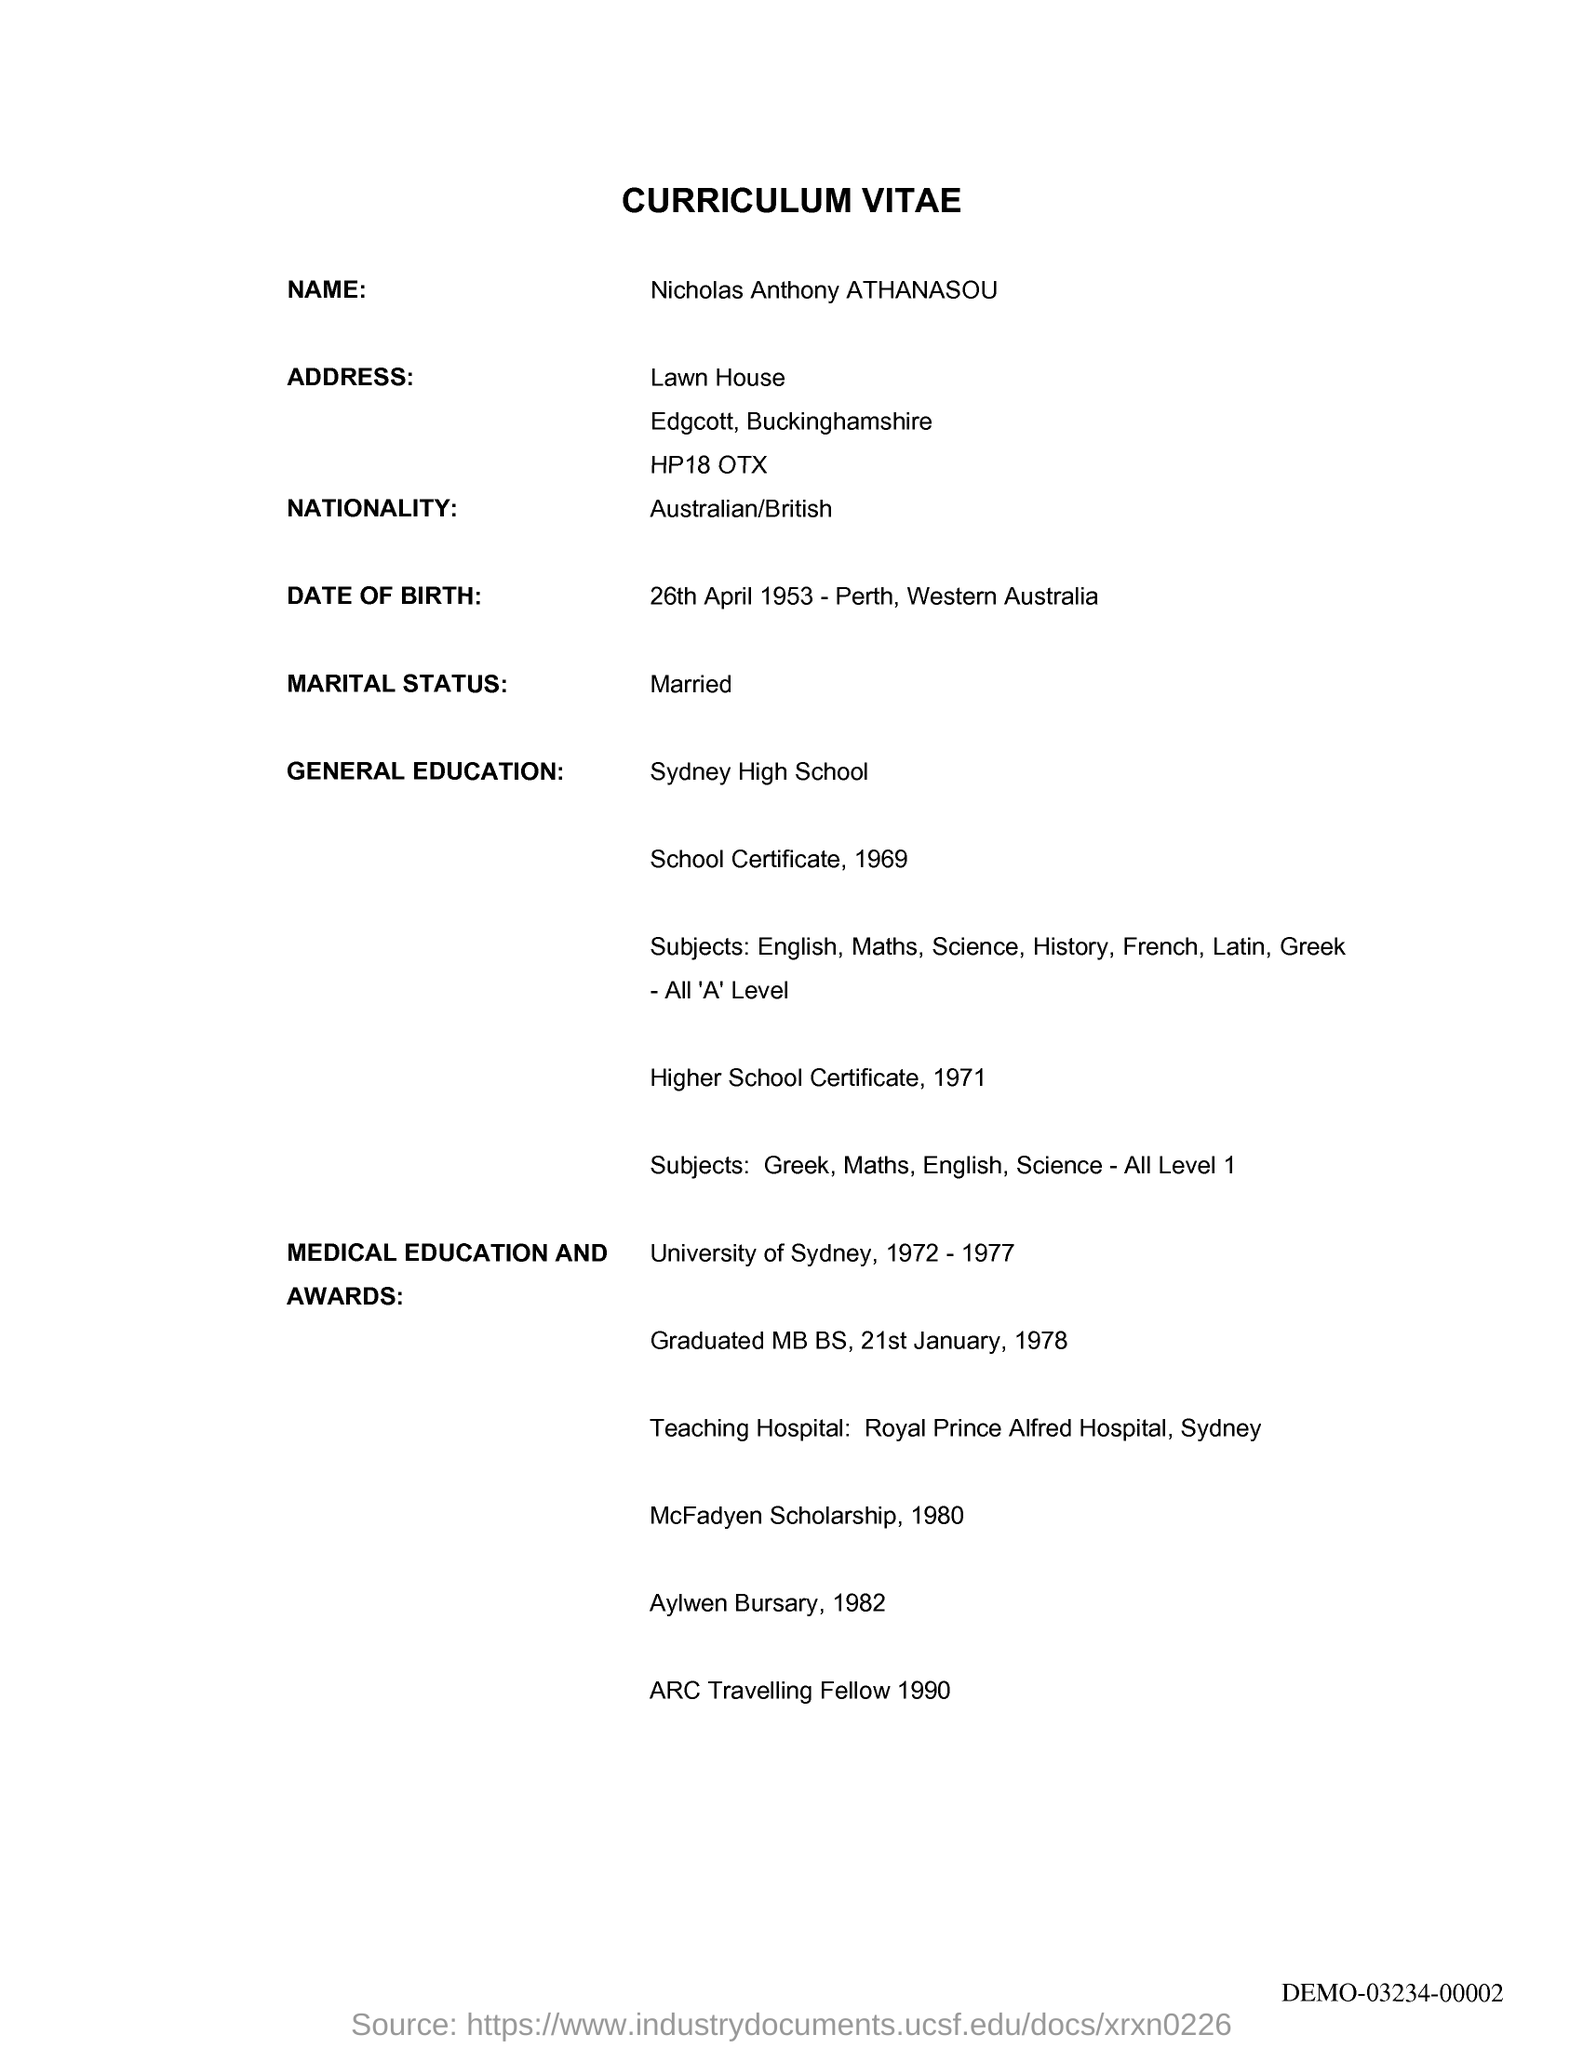What is the candidates name mentioned in the curriculum vitae?
Make the answer very short. Nicholas Anthony ATHANASOU. What is the Date of Birth of the applicant?
Make the answer very short. 26th April 1953. What is the marital status of the Applicant?
Your answer should be compact. Married. What is the nationality of the applicant?
Make the answer very short. Australian/British. 